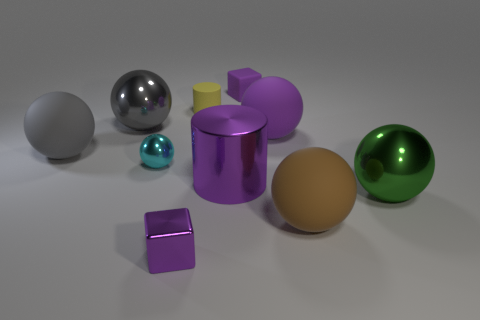What is the size of the other block that is the same color as the matte cube?
Ensure brevity in your answer.  Small. There is a purple cube behind the gray object that is left of the big metal ball behind the gray rubber thing; how big is it?
Your answer should be very brief. Small. What is the size of the rubber cylinder?
Your answer should be very brief. Small. There is a large rubber sphere on the left side of the small block that is on the right side of the big metallic cylinder; is there a big shiny object that is behind it?
Ensure brevity in your answer.  Yes. How many large things are either gray things or purple blocks?
Provide a short and direct response. 2. Is there anything else that is the same color as the big cylinder?
Offer a very short reply. Yes. Do the purple metallic cube on the left side of the brown matte ball and the brown rubber sphere have the same size?
Your answer should be very brief. No. The cube that is in front of the small cube behind the ball in front of the green thing is what color?
Give a very brief answer. Purple. The matte block is what color?
Your answer should be compact. Purple. Does the rubber block have the same color as the shiny cylinder?
Offer a terse response. Yes. 